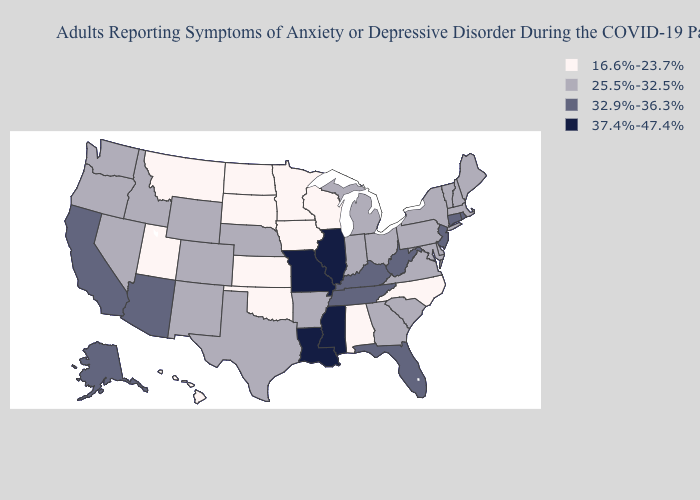Which states hav the highest value in the South?
Be succinct. Louisiana, Mississippi. Which states have the lowest value in the West?
Give a very brief answer. Hawaii, Montana, Utah. Does Louisiana have the highest value in the USA?
Keep it brief. Yes. Is the legend a continuous bar?
Be succinct. No. Does Illinois have the highest value in the MidWest?
Quick response, please. Yes. Name the states that have a value in the range 32.9%-36.3%?
Answer briefly. Alaska, Arizona, California, Connecticut, Florida, Kentucky, New Jersey, Rhode Island, Tennessee, West Virginia. What is the value of Nevada?
Give a very brief answer. 25.5%-32.5%. Does Tennessee have a lower value than Minnesota?
Be succinct. No. Which states hav the highest value in the Northeast?
Short answer required. Connecticut, New Jersey, Rhode Island. What is the lowest value in the USA?
Write a very short answer. 16.6%-23.7%. Name the states that have a value in the range 25.5%-32.5%?
Give a very brief answer. Arkansas, Colorado, Delaware, Georgia, Idaho, Indiana, Maine, Maryland, Massachusetts, Michigan, Nebraska, Nevada, New Hampshire, New Mexico, New York, Ohio, Oregon, Pennsylvania, South Carolina, Texas, Vermont, Virginia, Washington, Wyoming. What is the highest value in the USA?
Quick response, please. 37.4%-47.4%. Name the states that have a value in the range 37.4%-47.4%?
Be succinct. Illinois, Louisiana, Mississippi, Missouri. Among the states that border Maryland , does Virginia have the lowest value?
Concise answer only. Yes. Name the states that have a value in the range 37.4%-47.4%?
Short answer required. Illinois, Louisiana, Mississippi, Missouri. 